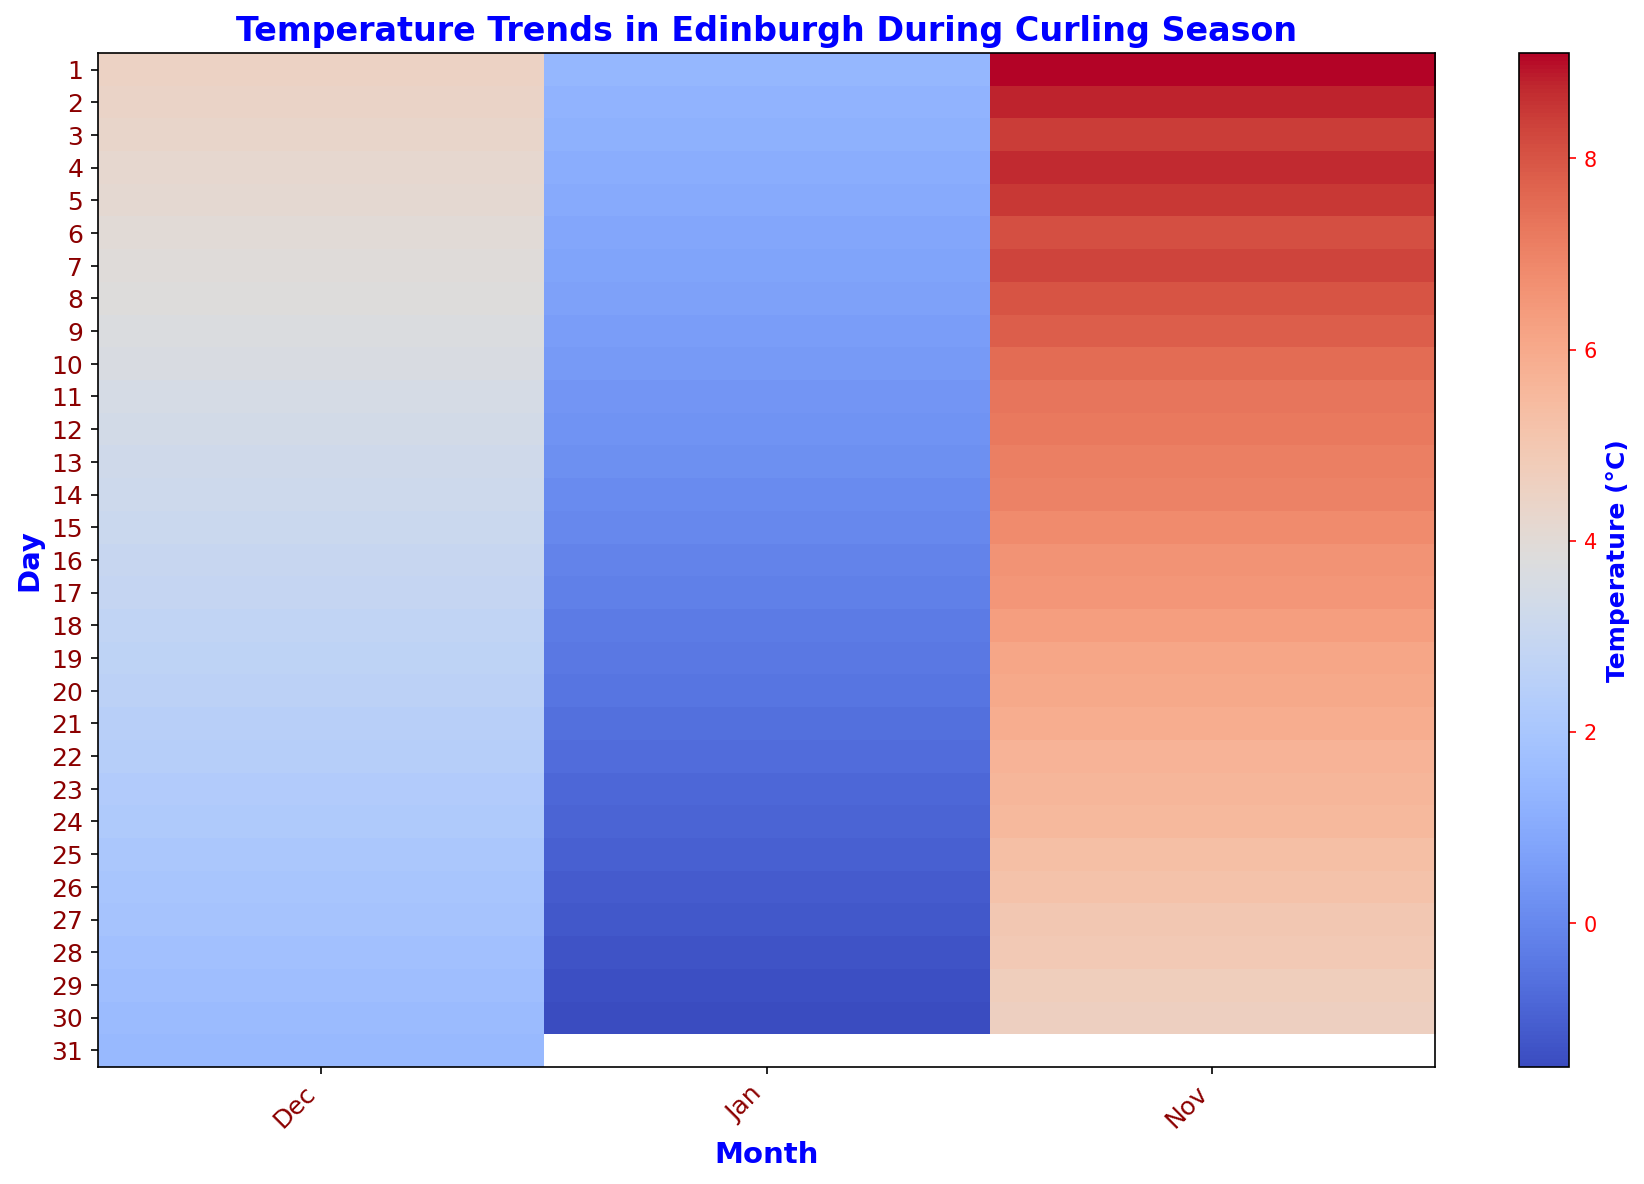What's the median temperature in January? To find the median, we look at the temperatures in January from the heatmap. Since there are 31 days in January, the median will be the 16th value when ordered. From the visual trend, this falls around 1.4°C.
Answer: 1.4°C Which month has the most significant temperature drop from the beginning to the end? Comparing the start and end temperatures for each month: November drops from 9.1°C to 4.6°C, December from 4.5°C to 1.5°C, and January from 1.4°C to -1.5°C. January shows the biggest drop.
Answer: January How does the temperature on November 15 compare to the temperature on December 15? On November 15, the temperature is around 6.8°C while on December 15 it’s approximately 3.1°C. So, November 15 is warmer than December 15.
Answer: November 15 is warmer During which month do we observe the first sub-zero temperature? The first sub-zero temperature appears in January, where temperatures drop below 0°C starting around January 16.
Answer: January What is the average temperature over the first week of January? Summing up the first 7 days of January: (1.4 + 1.3 + 1.2 + 1.1 + 1.0 + 0.9 + 0.8)/7 = 7.7 / 7 ≈ 1.1°C
Answer: 1.1°C Is the temperature on the last day of November higher or lower than the temperature on the first day of November? On the first of November, the temperature is 9.1°C, while on the last day it is 4.6°C. So, it is lower on the last day.
Answer: Lower Which day in December has the lowest temperature? By observing the heatmap's color gradient which darkens as the temperature lowers, the last day of December, the 31st, shows the darkest shade, indicating the lowest temperature of approximately 1.5°C.
Answer: December 31 During which month does the temperature graph start turning blue, indicating cooler temperatures? Blue shades start becoming more common from December onwards, indicating a trend toward cooler temperatures.
Answer: December What is the temperature difference between December 10 and December 30? The temperature on December 10 is around 3.6°C and on December 30 it is approximately 1.6°C. The difference is (3.6 - 1.6) = 2.0°C.
Answer: 2.0°C Is there any day where the temperature is exactly 0°C? If so, which day? By examining the color corresponding to 0°C which will be a neutral color between warm and cold, January 15 is where the temperature is exactly 0.0°C.
Answer: January 15 